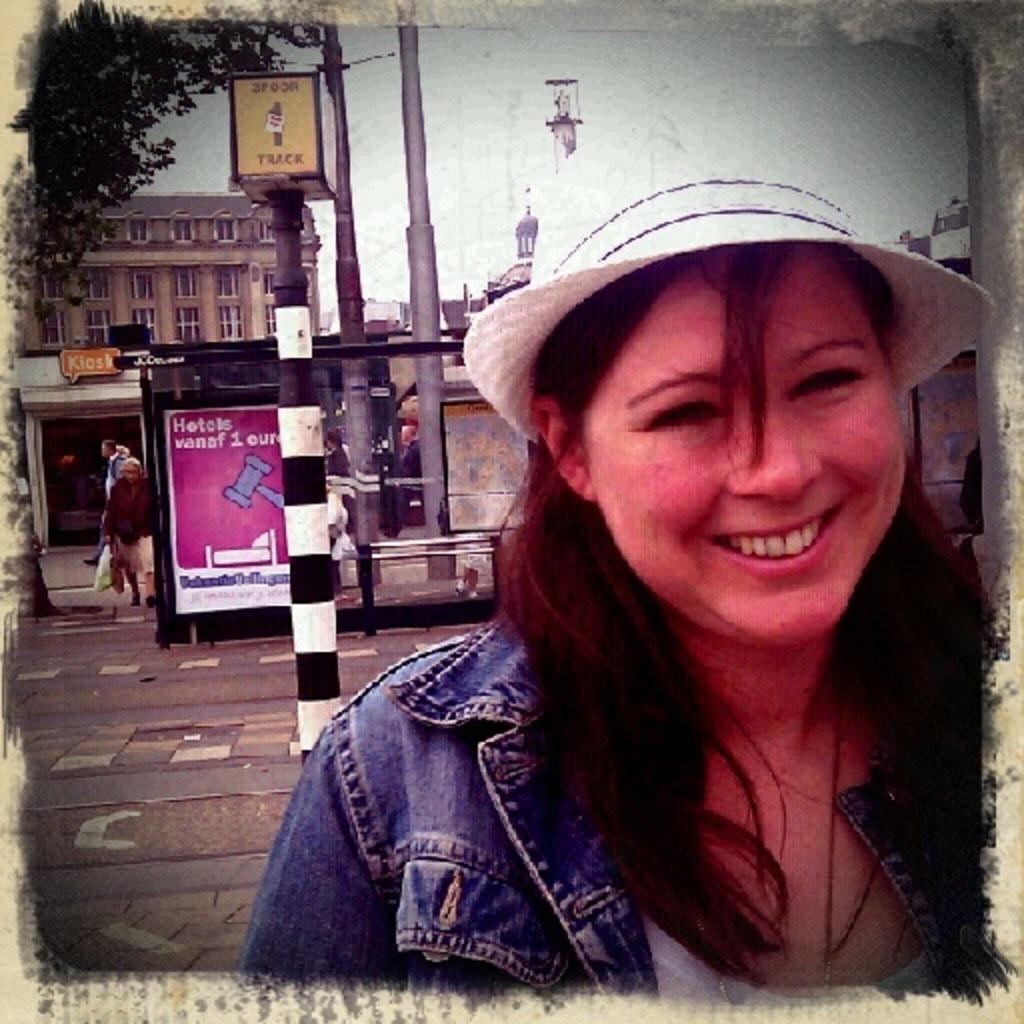Who is present in the image? There is a woman in the image. What can be seen on the path in the image? There are poles on the path in the image. What is visible in the background of the image? There is a tree and a building in the background of the image. What type of meeting is taking place in the hall in the image? There is no hall or meeting present in the image. 